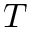<formula> <loc_0><loc_0><loc_500><loc_500>T</formula> 